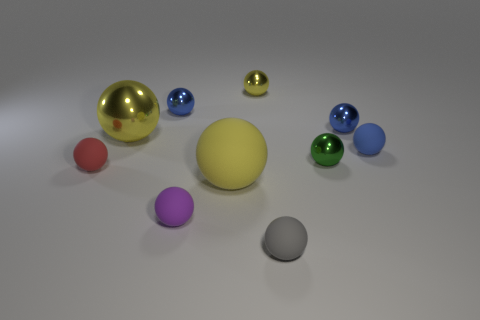What is the shape of the blue rubber object?
Your response must be concise. Sphere. Are there more tiny green shiny objects that are in front of the blue matte ball than small gray metal blocks?
Give a very brief answer. Yes. Is there a small rubber ball that has the same color as the large shiny ball?
Provide a succinct answer. No. There is a sphere that is the same size as the yellow rubber object; what color is it?
Your response must be concise. Yellow. There is a shiny object in front of the blue rubber sphere; what number of yellow things are behind it?
Your answer should be compact. 2. What number of things are either metal spheres to the right of the gray rubber object or small red rubber balls?
Your answer should be very brief. 3. How many blue things have the same material as the tiny purple object?
Your response must be concise. 1. What is the shape of the tiny thing that is the same color as the large matte thing?
Your response must be concise. Sphere. Are there the same number of small blue rubber spheres behind the tiny yellow shiny ball and tiny cyan metal things?
Make the answer very short. Yes. There is a yellow metal sphere that is to the left of the yellow rubber object; what size is it?
Keep it short and to the point. Large. 